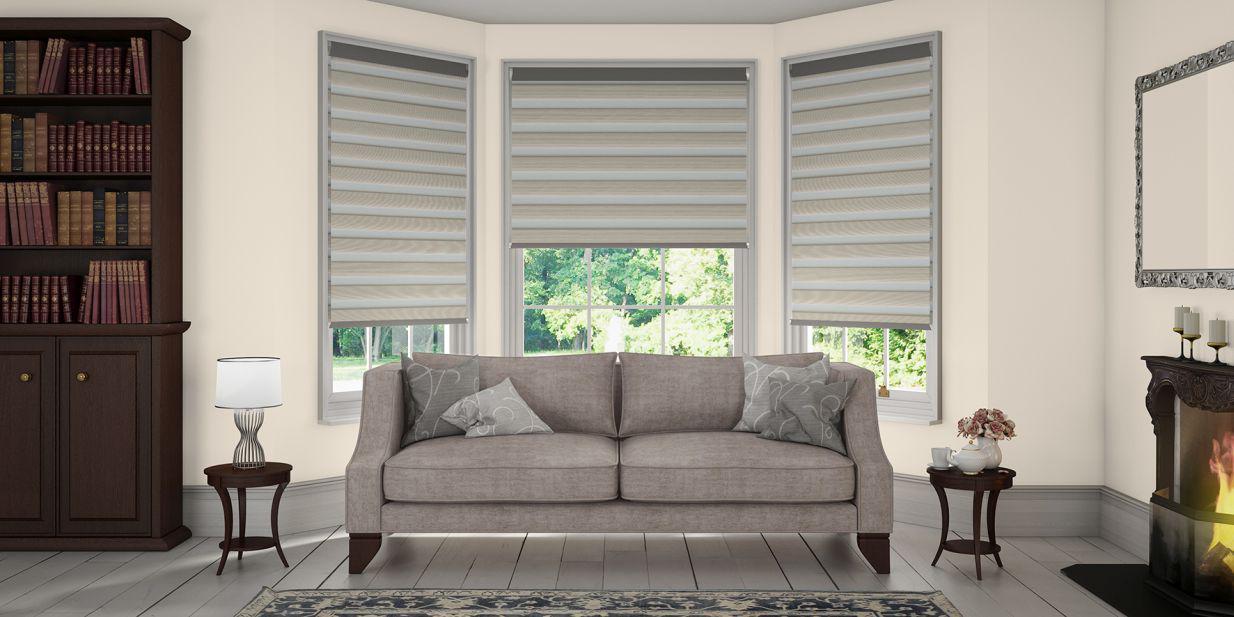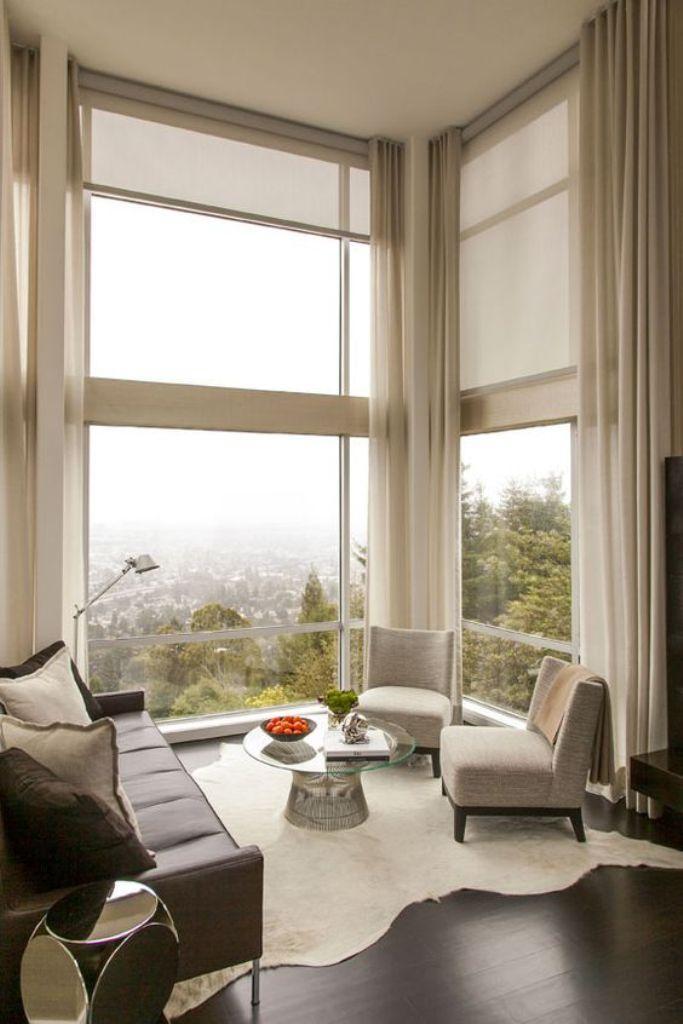The first image is the image on the left, the second image is the image on the right. Given the left and right images, does the statement "There are five blinds." hold true? Answer yes or no. Yes. The first image is the image on the left, the second image is the image on the right. Given the left and right images, does the statement "There are exactly five shades." hold true? Answer yes or no. Yes. 